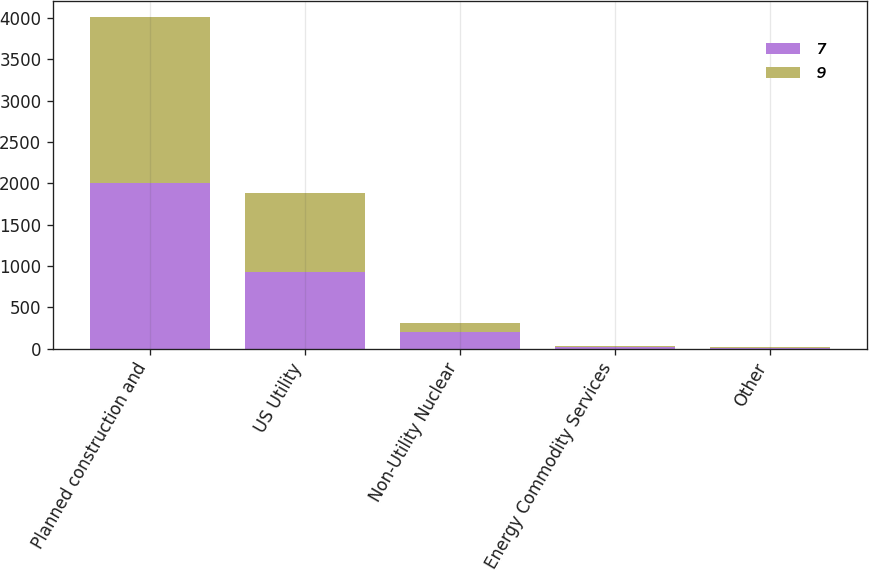Convert chart. <chart><loc_0><loc_0><loc_500><loc_500><stacked_bar_chart><ecel><fcel>Planned construction and<fcel>US Utility<fcel>Non-Utility Nuclear<fcel>Energy Commodity Services<fcel>Other<nl><fcel>7<fcel>2003<fcel>924<fcel>201<fcel>24<fcel>7<nl><fcel>9<fcel>2005<fcel>965<fcel>109<fcel>3<fcel>9<nl></chart> 